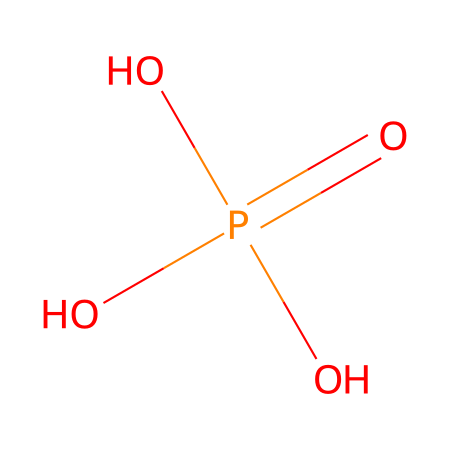What is the total number of oxygen atoms in this structure? The SMILES representation shows that the chemical consists of one phosphorus atom surrounded by four oxygen atoms. Counting the occurrences of 'O' in the SMILES string (OP(=O)(O)O), we find a total of 4 oxygen atoms.
Answer: four How many hydrogen atoms are present in the structure? In the SMILES, we can see that there are three hydroxyl (-OH) groups indicated by the three single bonded oxygen atoms. Each of these contributes one hydrogen atom, giving a total of three hydrogen atoms.
Answer: three What is the hybridization of the phosphorus atom? The phosphorus atom is bonded to four oxygen atoms; therefore, it undergoes sp3 hybridization to accommodate the four sigma bonds formed with the oxygen atoms and maintain tetrahedral geometry.
Answer: sp3 What type of functional groups are present in this compound? The structure contains phosphate groups, characterized by the presence of phosphorus bonded to four oxygens including hydroxyl groups. These functional groups are significant in biological molecules, such as ATP.
Answer: phosphate groups Does this structure suggest the compound is acidic? The presence of three hydroxyl groups suggests the ability to donate protons (H+), characteristic of acids. Therefore, this structure is likely to exhibit acidic properties in solution.
Answer: yes What is the charge of the phosphate group in this structure, considering protons? In its natural state, phosphate typically carries a -3 charge due to the three negatively charged oxygen atoms (after accounting for their bonds) and considering the proton interactions in aqueous solutions, making it an anion.
Answer: -3 What role does this chemical play in biosensing applications? Phosphate groups are involved in energy transfer and can act as recognition sites in biosensors, particularly for glucose sensing. They create functional interfaces necessary for sensor sensitivity and specificity.
Answer: recognition sites 